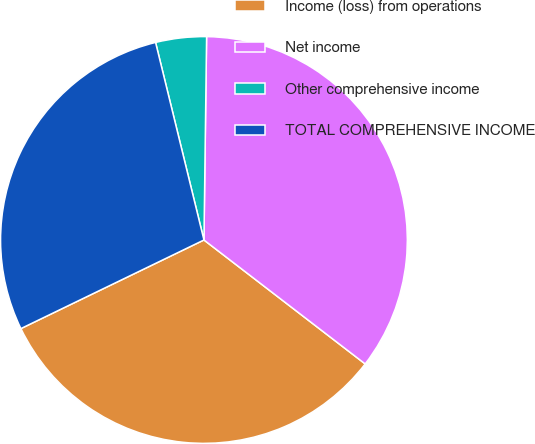Convert chart. <chart><loc_0><loc_0><loc_500><loc_500><pie_chart><fcel>Income (loss) from operations<fcel>Net income<fcel>Other comprehensive income<fcel>TOTAL COMPREHENSIVE INCOME<nl><fcel>32.39%<fcel>35.22%<fcel>4.03%<fcel>28.35%<nl></chart> 